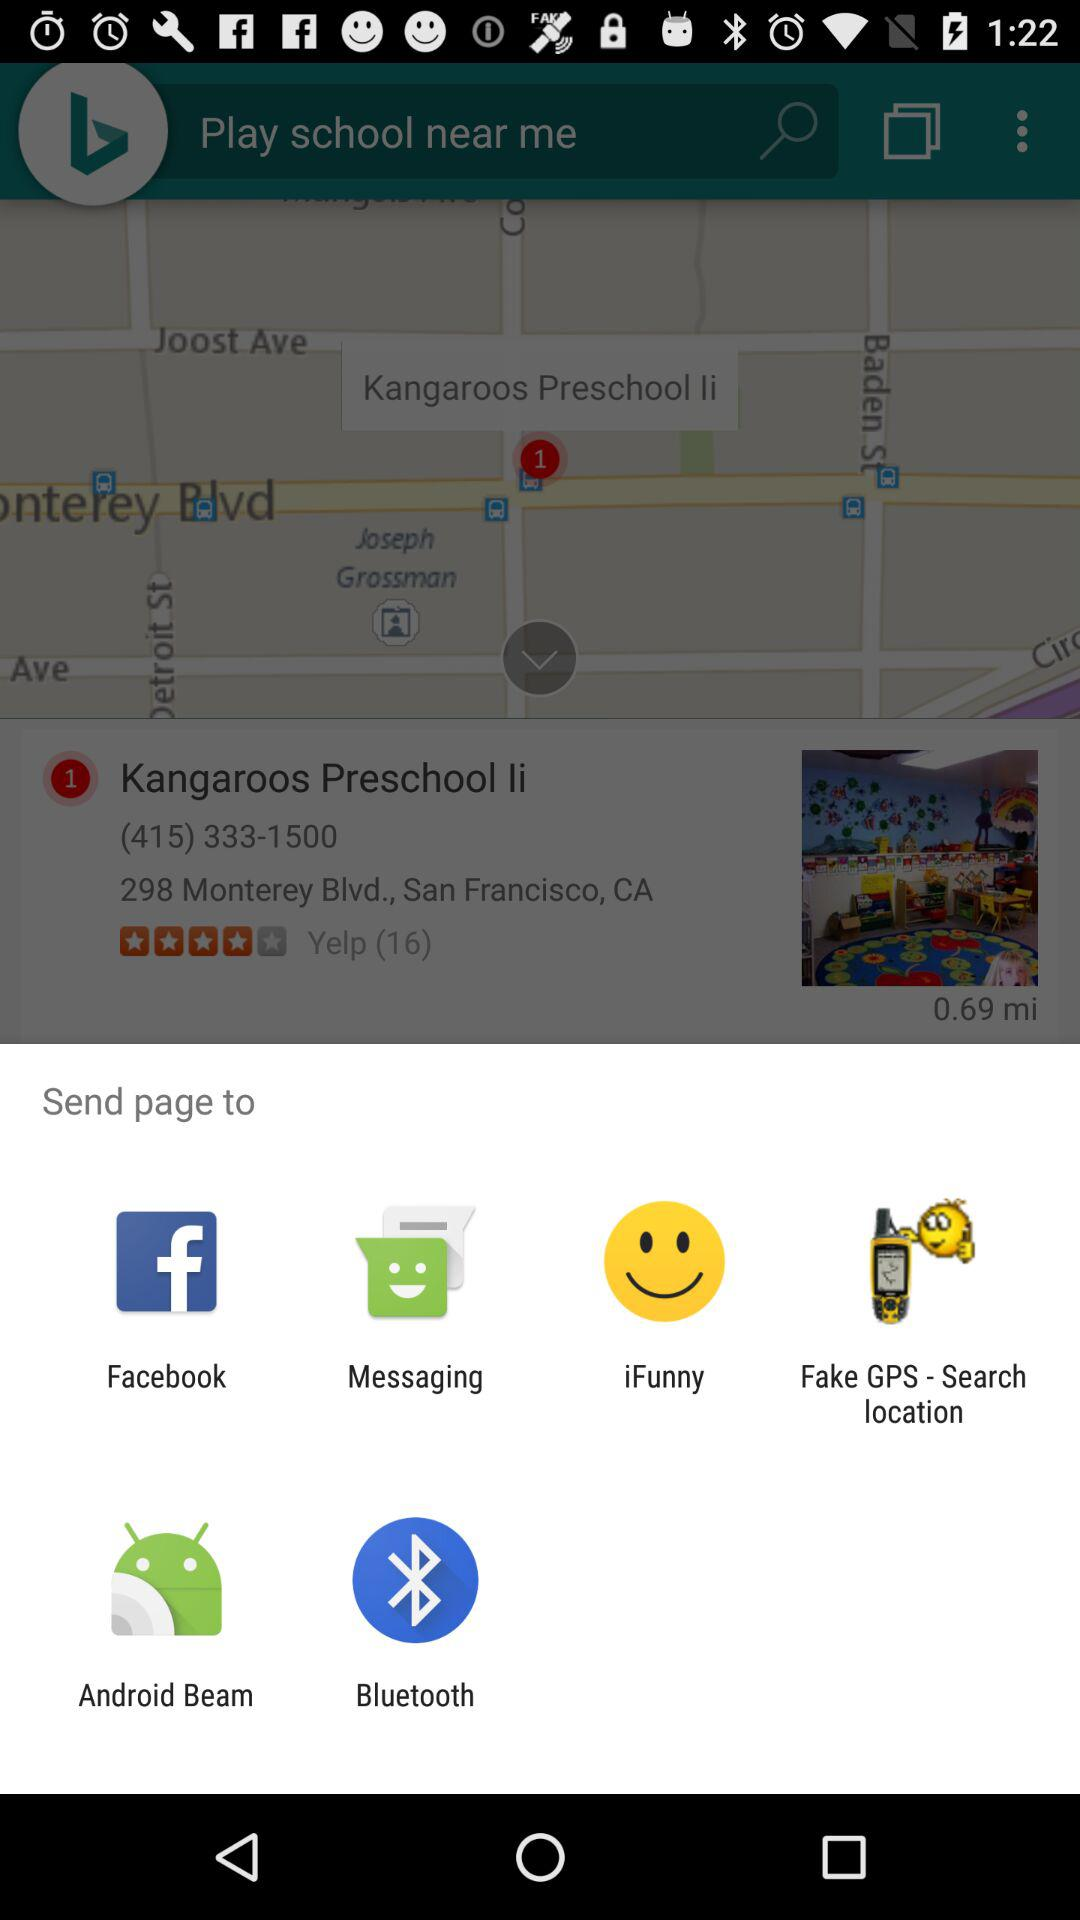Which application can I choose to share? The applications are "Facebook", "Messaging", "iFunny", "Fake GPS - Search location", "Android Beam" and "Bluetooth". 